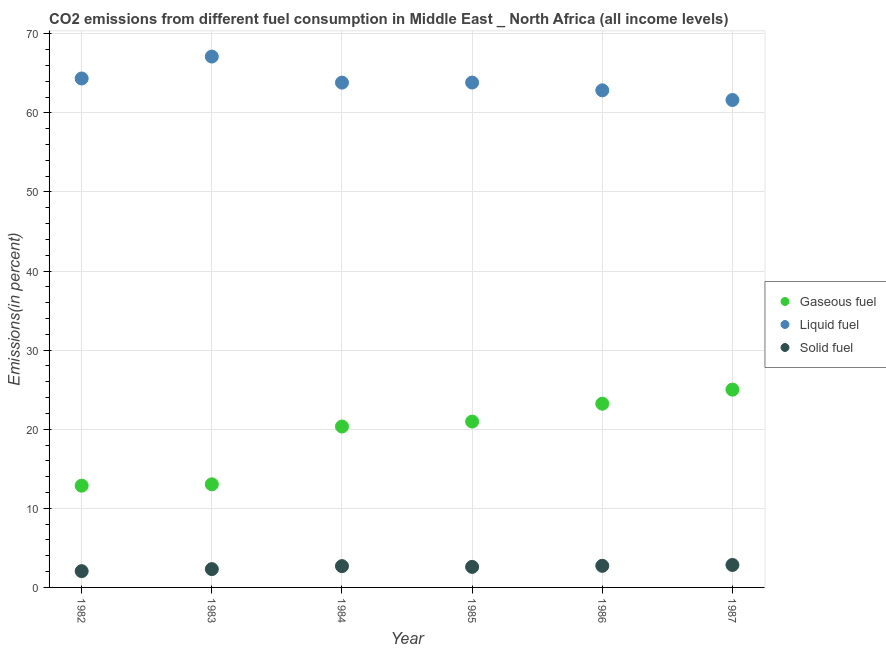How many different coloured dotlines are there?
Make the answer very short. 3. Is the number of dotlines equal to the number of legend labels?
Ensure brevity in your answer.  Yes. What is the percentage of liquid fuel emission in 1982?
Give a very brief answer. 64.35. Across all years, what is the maximum percentage of solid fuel emission?
Your answer should be very brief. 2.84. Across all years, what is the minimum percentage of gaseous fuel emission?
Offer a terse response. 12.86. In which year was the percentage of gaseous fuel emission maximum?
Your response must be concise. 1987. What is the total percentage of gaseous fuel emission in the graph?
Give a very brief answer. 115.45. What is the difference between the percentage of solid fuel emission in 1984 and that in 1986?
Make the answer very short. -0.04. What is the difference between the percentage of gaseous fuel emission in 1985 and the percentage of liquid fuel emission in 1984?
Keep it short and to the point. -42.86. What is the average percentage of liquid fuel emission per year?
Your answer should be very brief. 63.93. In the year 1983, what is the difference between the percentage of gaseous fuel emission and percentage of solid fuel emission?
Provide a succinct answer. 10.72. In how many years, is the percentage of solid fuel emission greater than 48 %?
Your answer should be very brief. 0. What is the ratio of the percentage of solid fuel emission in 1986 to that in 1987?
Give a very brief answer. 0.96. Is the percentage of solid fuel emission in 1984 less than that in 1985?
Provide a short and direct response. No. What is the difference between the highest and the second highest percentage of solid fuel emission?
Make the answer very short. 0.11. What is the difference between the highest and the lowest percentage of liquid fuel emission?
Give a very brief answer. 5.49. Is it the case that in every year, the sum of the percentage of gaseous fuel emission and percentage of liquid fuel emission is greater than the percentage of solid fuel emission?
Keep it short and to the point. Yes. Does the percentage of gaseous fuel emission monotonically increase over the years?
Your answer should be compact. Yes. Is the percentage of liquid fuel emission strictly less than the percentage of solid fuel emission over the years?
Keep it short and to the point. No. What is the difference between two consecutive major ticks on the Y-axis?
Make the answer very short. 10. Does the graph contain grids?
Provide a succinct answer. Yes. Where does the legend appear in the graph?
Keep it short and to the point. Center right. What is the title of the graph?
Offer a very short reply. CO2 emissions from different fuel consumption in Middle East _ North Africa (all income levels). What is the label or title of the Y-axis?
Your answer should be very brief. Emissions(in percent). What is the Emissions(in percent) in Gaseous fuel in 1982?
Ensure brevity in your answer.  12.86. What is the Emissions(in percent) of Liquid fuel in 1982?
Your answer should be very brief. 64.35. What is the Emissions(in percent) in Solid fuel in 1982?
Offer a terse response. 2.06. What is the Emissions(in percent) in Gaseous fuel in 1983?
Your answer should be compact. 13.04. What is the Emissions(in percent) of Liquid fuel in 1983?
Make the answer very short. 67.12. What is the Emissions(in percent) of Solid fuel in 1983?
Provide a short and direct response. 2.32. What is the Emissions(in percent) in Gaseous fuel in 1984?
Provide a succinct answer. 20.35. What is the Emissions(in percent) in Liquid fuel in 1984?
Provide a succinct answer. 63.83. What is the Emissions(in percent) in Solid fuel in 1984?
Provide a succinct answer. 2.69. What is the Emissions(in percent) of Gaseous fuel in 1985?
Your response must be concise. 20.97. What is the Emissions(in percent) in Liquid fuel in 1985?
Your answer should be compact. 63.83. What is the Emissions(in percent) of Solid fuel in 1985?
Give a very brief answer. 2.6. What is the Emissions(in percent) in Gaseous fuel in 1986?
Your answer should be compact. 23.23. What is the Emissions(in percent) of Liquid fuel in 1986?
Offer a very short reply. 62.85. What is the Emissions(in percent) in Solid fuel in 1986?
Ensure brevity in your answer.  2.73. What is the Emissions(in percent) in Gaseous fuel in 1987?
Offer a terse response. 25.01. What is the Emissions(in percent) of Liquid fuel in 1987?
Offer a very short reply. 61.63. What is the Emissions(in percent) in Solid fuel in 1987?
Your answer should be compact. 2.84. Across all years, what is the maximum Emissions(in percent) of Gaseous fuel?
Give a very brief answer. 25.01. Across all years, what is the maximum Emissions(in percent) of Liquid fuel?
Give a very brief answer. 67.12. Across all years, what is the maximum Emissions(in percent) in Solid fuel?
Your answer should be compact. 2.84. Across all years, what is the minimum Emissions(in percent) in Gaseous fuel?
Your answer should be compact. 12.86. Across all years, what is the minimum Emissions(in percent) in Liquid fuel?
Provide a short and direct response. 61.63. Across all years, what is the minimum Emissions(in percent) in Solid fuel?
Your answer should be compact. 2.06. What is the total Emissions(in percent) in Gaseous fuel in the graph?
Ensure brevity in your answer.  115.45. What is the total Emissions(in percent) in Liquid fuel in the graph?
Give a very brief answer. 383.61. What is the total Emissions(in percent) of Solid fuel in the graph?
Keep it short and to the point. 15.24. What is the difference between the Emissions(in percent) of Gaseous fuel in 1982 and that in 1983?
Make the answer very short. -0.17. What is the difference between the Emissions(in percent) of Liquid fuel in 1982 and that in 1983?
Keep it short and to the point. -2.77. What is the difference between the Emissions(in percent) in Solid fuel in 1982 and that in 1983?
Make the answer very short. -0.26. What is the difference between the Emissions(in percent) of Gaseous fuel in 1982 and that in 1984?
Ensure brevity in your answer.  -7.48. What is the difference between the Emissions(in percent) of Liquid fuel in 1982 and that in 1984?
Give a very brief answer. 0.52. What is the difference between the Emissions(in percent) of Solid fuel in 1982 and that in 1984?
Your answer should be compact. -0.63. What is the difference between the Emissions(in percent) in Gaseous fuel in 1982 and that in 1985?
Provide a succinct answer. -8.11. What is the difference between the Emissions(in percent) in Liquid fuel in 1982 and that in 1985?
Offer a very short reply. 0.52. What is the difference between the Emissions(in percent) of Solid fuel in 1982 and that in 1985?
Give a very brief answer. -0.54. What is the difference between the Emissions(in percent) of Gaseous fuel in 1982 and that in 1986?
Provide a succinct answer. -10.37. What is the difference between the Emissions(in percent) in Liquid fuel in 1982 and that in 1986?
Your answer should be very brief. 1.5. What is the difference between the Emissions(in percent) of Solid fuel in 1982 and that in 1986?
Provide a succinct answer. -0.67. What is the difference between the Emissions(in percent) of Gaseous fuel in 1982 and that in 1987?
Give a very brief answer. -12.14. What is the difference between the Emissions(in percent) in Liquid fuel in 1982 and that in 1987?
Offer a terse response. 2.72. What is the difference between the Emissions(in percent) of Solid fuel in 1982 and that in 1987?
Make the answer very short. -0.78. What is the difference between the Emissions(in percent) of Gaseous fuel in 1983 and that in 1984?
Your answer should be very brief. -7.31. What is the difference between the Emissions(in percent) in Liquid fuel in 1983 and that in 1984?
Ensure brevity in your answer.  3.3. What is the difference between the Emissions(in percent) in Solid fuel in 1983 and that in 1984?
Make the answer very short. -0.38. What is the difference between the Emissions(in percent) in Gaseous fuel in 1983 and that in 1985?
Your answer should be compact. -7.93. What is the difference between the Emissions(in percent) of Liquid fuel in 1983 and that in 1985?
Keep it short and to the point. 3.29. What is the difference between the Emissions(in percent) in Solid fuel in 1983 and that in 1985?
Offer a terse response. -0.28. What is the difference between the Emissions(in percent) in Gaseous fuel in 1983 and that in 1986?
Ensure brevity in your answer.  -10.19. What is the difference between the Emissions(in percent) in Liquid fuel in 1983 and that in 1986?
Offer a very short reply. 4.27. What is the difference between the Emissions(in percent) in Solid fuel in 1983 and that in 1986?
Your answer should be very brief. -0.42. What is the difference between the Emissions(in percent) of Gaseous fuel in 1983 and that in 1987?
Provide a succinct answer. -11.97. What is the difference between the Emissions(in percent) of Liquid fuel in 1983 and that in 1987?
Offer a very short reply. 5.49. What is the difference between the Emissions(in percent) of Solid fuel in 1983 and that in 1987?
Provide a short and direct response. -0.53. What is the difference between the Emissions(in percent) of Gaseous fuel in 1984 and that in 1985?
Make the answer very short. -0.62. What is the difference between the Emissions(in percent) of Liquid fuel in 1984 and that in 1985?
Provide a succinct answer. -0.01. What is the difference between the Emissions(in percent) in Solid fuel in 1984 and that in 1985?
Offer a terse response. 0.09. What is the difference between the Emissions(in percent) in Gaseous fuel in 1984 and that in 1986?
Your answer should be very brief. -2.88. What is the difference between the Emissions(in percent) in Liquid fuel in 1984 and that in 1986?
Your answer should be very brief. 0.98. What is the difference between the Emissions(in percent) of Solid fuel in 1984 and that in 1986?
Keep it short and to the point. -0.04. What is the difference between the Emissions(in percent) in Gaseous fuel in 1984 and that in 1987?
Provide a short and direct response. -4.66. What is the difference between the Emissions(in percent) of Liquid fuel in 1984 and that in 1987?
Your answer should be very brief. 2.2. What is the difference between the Emissions(in percent) in Solid fuel in 1984 and that in 1987?
Provide a short and direct response. -0.15. What is the difference between the Emissions(in percent) of Gaseous fuel in 1985 and that in 1986?
Offer a terse response. -2.26. What is the difference between the Emissions(in percent) in Liquid fuel in 1985 and that in 1986?
Offer a terse response. 0.98. What is the difference between the Emissions(in percent) in Solid fuel in 1985 and that in 1986?
Give a very brief answer. -0.13. What is the difference between the Emissions(in percent) in Gaseous fuel in 1985 and that in 1987?
Ensure brevity in your answer.  -4.04. What is the difference between the Emissions(in percent) in Liquid fuel in 1985 and that in 1987?
Give a very brief answer. 2.21. What is the difference between the Emissions(in percent) in Solid fuel in 1985 and that in 1987?
Your answer should be compact. -0.24. What is the difference between the Emissions(in percent) in Gaseous fuel in 1986 and that in 1987?
Ensure brevity in your answer.  -1.78. What is the difference between the Emissions(in percent) in Liquid fuel in 1986 and that in 1987?
Your response must be concise. 1.22. What is the difference between the Emissions(in percent) of Solid fuel in 1986 and that in 1987?
Ensure brevity in your answer.  -0.11. What is the difference between the Emissions(in percent) in Gaseous fuel in 1982 and the Emissions(in percent) in Liquid fuel in 1983?
Keep it short and to the point. -54.26. What is the difference between the Emissions(in percent) of Gaseous fuel in 1982 and the Emissions(in percent) of Solid fuel in 1983?
Offer a very short reply. 10.55. What is the difference between the Emissions(in percent) of Liquid fuel in 1982 and the Emissions(in percent) of Solid fuel in 1983?
Ensure brevity in your answer.  62.03. What is the difference between the Emissions(in percent) of Gaseous fuel in 1982 and the Emissions(in percent) of Liquid fuel in 1984?
Your answer should be very brief. -50.96. What is the difference between the Emissions(in percent) of Gaseous fuel in 1982 and the Emissions(in percent) of Solid fuel in 1984?
Keep it short and to the point. 10.17. What is the difference between the Emissions(in percent) in Liquid fuel in 1982 and the Emissions(in percent) in Solid fuel in 1984?
Ensure brevity in your answer.  61.66. What is the difference between the Emissions(in percent) of Gaseous fuel in 1982 and the Emissions(in percent) of Liquid fuel in 1985?
Provide a short and direct response. -50.97. What is the difference between the Emissions(in percent) of Gaseous fuel in 1982 and the Emissions(in percent) of Solid fuel in 1985?
Keep it short and to the point. 10.27. What is the difference between the Emissions(in percent) in Liquid fuel in 1982 and the Emissions(in percent) in Solid fuel in 1985?
Your answer should be very brief. 61.75. What is the difference between the Emissions(in percent) in Gaseous fuel in 1982 and the Emissions(in percent) in Liquid fuel in 1986?
Provide a short and direct response. -49.99. What is the difference between the Emissions(in percent) in Gaseous fuel in 1982 and the Emissions(in percent) in Solid fuel in 1986?
Offer a terse response. 10.13. What is the difference between the Emissions(in percent) in Liquid fuel in 1982 and the Emissions(in percent) in Solid fuel in 1986?
Your answer should be compact. 61.62. What is the difference between the Emissions(in percent) in Gaseous fuel in 1982 and the Emissions(in percent) in Liquid fuel in 1987?
Offer a very short reply. -48.76. What is the difference between the Emissions(in percent) in Gaseous fuel in 1982 and the Emissions(in percent) in Solid fuel in 1987?
Your answer should be very brief. 10.02. What is the difference between the Emissions(in percent) of Liquid fuel in 1982 and the Emissions(in percent) of Solid fuel in 1987?
Keep it short and to the point. 61.51. What is the difference between the Emissions(in percent) in Gaseous fuel in 1983 and the Emissions(in percent) in Liquid fuel in 1984?
Your answer should be very brief. -50.79. What is the difference between the Emissions(in percent) of Gaseous fuel in 1983 and the Emissions(in percent) of Solid fuel in 1984?
Provide a succinct answer. 10.34. What is the difference between the Emissions(in percent) of Liquid fuel in 1983 and the Emissions(in percent) of Solid fuel in 1984?
Provide a short and direct response. 64.43. What is the difference between the Emissions(in percent) of Gaseous fuel in 1983 and the Emissions(in percent) of Liquid fuel in 1985?
Your response must be concise. -50.8. What is the difference between the Emissions(in percent) of Gaseous fuel in 1983 and the Emissions(in percent) of Solid fuel in 1985?
Your answer should be compact. 10.44. What is the difference between the Emissions(in percent) of Liquid fuel in 1983 and the Emissions(in percent) of Solid fuel in 1985?
Your answer should be very brief. 64.52. What is the difference between the Emissions(in percent) of Gaseous fuel in 1983 and the Emissions(in percent) of Liquid fuel in 1986?
Make the answer very short. -49.81. What is the difference between the Emissions(in percent) of Gaseous fuel in 1983 and the Emissions(in percent) of Solid fuel in 1986?
Give a very brief answer. 10.3. What is the difference between the Emissions(in percent) in Liquid fuel in 1983 and the Emissions(in percent) in Solid fuel in 1986?
Provide a succinct answer. 64.39. What is the difference between the Emissions(in percent) of Gaseous fuel in 1983 and the Emissions(in percent) of Liquid fuel in 1987?
Your response must be concise. -48.59. What is the difference between the Emissions(in percent) of Gaseous fuel in 1983 and the Emissions(in percent) of Solid fuel in 1987?
Keep it short and to the point. 10.2. What is the difference between the Emissions(in percent) in Liquid fuel in 1983 and the Emissions(in percent) in Solid fuel in 1987?
Your response must be concise. 64.28. What is the difference between the Emissions(in percent) in Gaseous fuel in 1984 and the Emissions(in percent) in Liquid fuel in 1985?
Ensure brevity in your answer.  -43.49. What is the difference between the Emissions(in percent) in Gaseous fuel in 1984 and the Emissions(in percent) in Solid fuel in 1985?
Your response must be concise. 17.75. What is the difference between the Emissions(in percent) of Liquid fuel in 1984 and the Emissions(in percent) of Solid fuel in 1985?
Your response must be concise. 61.23. What is the difference between the Emissions(in percent) of Gaseous fuel in 1984 and the Emissions(in percent) of Liquid fuel in 1986?
Your response must be concise. -42.5. What is the difference between the Emissions(in percent) in Gaseous fuel in 1984 and the Emissions(in percent) in Solid fuel in 1986?
Make the answer very short. 17.61. What is the difference between the Emissions(in percent) in Liquid fuel in 1984 and the Emissions(in percent) in Solid fuel in 1986?
Your answer should be compact. 61.09. What is the difference between the Emissions(in percent) in Gaseous fuel in 1984 and the Emissions(in percent) in Liquid fuel in 1987?
Your answer should be very brief. -41.28. What is the difference between the Emissions(in percent) in Gaseous fuel in 1984 and the Emissions(in percent) in Solid fuel in 1987?
Make the answer very short. 17.51. What is the difference between the Emissions(in percent) of Liquid fuel in 1984 and the Emissions(in percent) of Solid fuel in 1987?
Your answer should be compact. 60.98. What is the difference between the Emissions(in percent) in Gaseous fuel in 1985 and the Emissions(in percent) in Liquid fuel in 1986?
Provide a succinct answer. -41.88. What is the difference between the Emissions(in percent) in Gaseous fuel in 1985 and the Emissions(in percent) in Solid fuel in 1986?
Your response must be concise. 18.24. What is the difference between the Emissions(in percent) of Liquid fuel in 1985 and the Emissions(in percent) of Solid fuel in 1986?
Your response must be concise. 61.1. What is the difference between the Emissions(in percent) in Gaseous fuel in 1985 and the Emissions(in percent) in Liquid fuel in 1987?
Offer a terse response. -40.66. What is the difference between the Emissions(in percent) in Gaseous fuel in 1985 and the Emissions(in percent) in Solid fuel in 1987?
Your response must be concise. 18.13. What is the difference between the Emissions(in percent) in Liquid fuel in 1985 and the Emissions(in percent) in Solid fuel in 1987?
Your answer should be compact. 60.99. What is the difference between the Emissions(in percent) of Gaseous fuel in 1986 and the Emissions(in percent) of Liquid fuel in 1987?
Provide a succinct answer. -38.4. What is the difference between the Emissions(in percent) of Gaseous fuel in 1986 and the Emissions(in percent) of Solid fuel in 1987?
Give a very brief answer. 20.39. What is the difference between the Emissions(in percent) in Liquid fuel in 1986 and the Emissions(in percent) in Solid fuel in 1987?
Your answer should be very brief. 60.01. What is the average Emissions(in percent) of Gaseous fuel per year?
Your answer should be very brief. 19.24. What is the average Emissions(in percent) of Liquid fuel per year?
Give a very brief answer. 63.93. What is the average Emissions(in percent) of Solid fuel per year?
Ensure brevity in your answer.  2.54. In the year 1982, what is the difference between the Emissions(in percent) in Gaseous fuel and Emissions(in percent) in Liquid fuel?
Your answer should be very brief. -51.49. In the year 1982, what is the difference between the Emissions(in percent) of Gaseous fuel and Emissions(in percent) of Solid fuel?
Keep it short and to the point. 10.81. In the year 1982, what is the difference between the Emissions(in percent) in Liquid fuel and Emissions(in percent) in Solid fuel?
Your answer should be very brief. 62.29. In the year 1983, what is the difference between the Emissions(in percent) in Gaseous fuel and Emissions(in percent) in Liquid fuel?
Offer a terse response. -54.09. In the year 1983, what is the difference between the Emissions(in percent) of Gaseous fuel and Emissions(in percent) of Solid fuel?
Make the answer very short. 10.72. In the year 1983, what is the difference between the Emissions(in percent) of Liquid fuel and Emissions(in percent) of Solid fuel?
Offer a very short reply. 64.81. In the year 1984, what is the difference between the Emissions(in percent) in Gaseous fuel and Emissions(in percent) in Liquid fuel?
Keep it short and to the point. -43.48. In the year 1984, what is the difference between the Emissions(in percent) in Gaseous fuel and Emissions(in percent) in Solid fuel?
Your answer should be very brief. 17.65. In the year 1984, what is the difference between the Emissions(in percent) in Liquid fuel and Emissions(in percent) in Solid fuel?
Keep it short and to the point. 61.13. In the year 1985, what is the difference between the Emissions(in percent) in Gaseous fuel and Emissions(in percent) in Liquid fuel?
Offer a very short reply. -42.86. In the year 1985, what is the difference between the Emissions(in percent) in Gaseous fuel and Emissions(in percent) in Solid fuel?
Give a very brief answer. 18.37. In the year 1985, what is the difference between the Emissions(in percent) in Liquid fuel and Emissions(in percent) in Solid fuel?
Provide a succinct answer. 61.23. In the year 1986, what is the difference between the Emissions(in percent) of Gaseous fuel and Emissions(in percent) of Liquid fuel?
Offer a very short reply. -39.62. In the year 1986, what is the difference between the Emissions(in percent) of Gaseous fuel and Emissions(in percent) of Solid fuel?
Your response must be concise. 20.5. In the year 1986, what is the difference between the Emissions(in percent) in Liquid fuel and Emissions(in percent) in Solid fuel?
Ensure brevity in your answer.  60.12. In the year 1987, what is the difference between the Emissions(in percent) in Gaseous fuel and Emissions(in percent) in Liquid fuel?
Make the answer very short. -36.62. In the year 1987, what is the difference between the Emissions(in percent) of Gaseous fuel and Emissions(in percent) of Solid fuel?
Your response must be concise. 22.17. In the year 1987, what is the difference between the Emissions(in percent) of Liquid fuel and Emissions(in percent) of Solid fuel?
Offer a very short reply. 58.79. What is the ratio of the Emissions(in percent) of Gaseous fuel in 1982 to that in 1983?
Keep it short and to the point. 0.99. What is the ratio of the Emissions(in percent) in Liquid fuel in 1982 to that in 1983?
Offer a terse response. 0.96. What is the ratio of the Emissions(in percent) in Solid fuel in 1982 to that in 1983?
Your response must be concise. 0.89. What is the ratio of the Emissions(in percent) of Gaseous fuel in 1982 to that in 1984?
Provide a short and direct response. 0.63. What is the ratio of the Emissions(in percent) in Liquid fuel in 1982 to that in 1984?
Give a very brief answer. 1.01. What is the ratio of the Emissions(in percent) of Solid fuel in 1982 to that in 1984?
Offer a very short reply. 0.76. What is the ratio of the Emissions(in percent) in Gaseous fuel in 1982 to that in 1985?
Your response must be concise. 0.61. What is the ratio of the Emissions(in percent) of Liquid fuel in 1982 to that in 1985?
Offer a terse response. 1.01. What is the ratio of the Emissions(in percent) in Solid fuel in 1982 to that in 1985?
Ensure brevity in your answer.  0.79. What is the ratio of the Emissions(in percent) in Gaseous fuel in 1982 to that in 1986?
Provide a short and direct response. 0.55. What is the ratio of the Emissions(in percent) in Liquid fuel in 1982 to that in 1986?
Ensure brevity in your answer.  1.02. What is the ratio of the Emissions(in percent) of Solid fuel in 1982 to that in 1986?
Your answer should be compact. 0.75. What is the ratio of the Emissions(in percent) of Gaseous fuel in 1982 to that in 1987?
Your answer should be very brief. 0.51. What is the ratio of the Emissions(in percent) in Liquid fuel in 1982 to that in 1987?
Make the answer very short. 1.04. What is the ratio of the Emissions(in percent) of Solid fuel in 1982 to that in 1987?
Offer a terse response. 0.72. What is the ratio of the Emissions(in percent) in Gaseous fuel in 1983 to that in 1984?
Provide a succinct answer. 0.64. What is the ratio of the Emissions(in percent) of Liquid fuel in 1983 to that in 1984?
Your answer should be very brief. 1.05. What is the ratio of the Emissions(in percent) of Solid fuel in 1983 to that in 1984?
Ensure brevity in your answer.  0.86. What is the ratio of the Emissions(in percent) of Gaseous fuel in 1983 to that in 1985?
Your answer should be very brief. 0.62. What is the ratio of the Emissions(in percent) in Liquid fuel in 1983 to that in 1985?
Your response must be concise. 1.05. What is the ratio of the Emissions(in percent) in Solid fuel in 1983 to that in 1985?
Ensure brevity in your answer.  0.89. What is the ratio of the Emissions(in percent) in Gaseous fuel in 1983 to that in 1986?
Give a very brief answer. 0.56. What is the ratio of the Emissions(in percent) in Liquid fuel in 1983 to that in 1986?
Provide a short and direct response. 1.07. What is the ratio of the Emissions(in percent) in Solid fuel in 1983 to that in 1986?
Keep it short and to the point. 0.85. What is the ratio of the Emissions(in percent) of Gaseous fuel in 1983 to that in 1987?
Provide a short and direct response. 0.52. What is the ratio of the Emissions(in percent) of Liquid fuel in 1983 to that in 1987?
Provide a short and direct response. 1.09. What is the ratio of the Emissions(in percent) of Solid fuel in 1983 to that in 1987?
Your answer should be compact. 0.82. What is the ratio of the Emissions(in percent) in Gaseous fuel in 1984 to that in 1985?
Your answer should be very brief. 0.97. What is the ratio of the Emissions(in percent) of Liquid fuel in 1984 to that in 1985?
Your response must be concise. 1. What is the ratio of the Emissions(in percent) of Solid fuel in 1984 to that in 1985?
Your answer should be very brief. 1.04. What is the ratio of the Emissions(in percent) of Gaseous fuel in 1984 to that in 1986?
Keep it short and to the point. 0.88. What is the ratio of the Emissions(in percent) of Liquid fuel in 1984 to that in 1986?
Your answer should be compact. 1.02. What is the ratio of the Emissions(in percent) of Solid fuel in 1984 to that in 1986?
Your answer should be very brief. 0.99. What is the ratio of the Emissions(in percent) in Gaseous fuel in 1984 to that in 1987?
Your answer should be very brief. 0.81. What is the ratio of the Emissions(in percent) in Liquid fuel in 1984 to that in 1987?
Keep it short and to the point. 1.04. What is the ratio of the Emissions(in percent) of Solid fuel in 1984 to that in 1987?
Your answer should be very brief. 0.95. What is the ratio of the Emissions(in percent) in Gaseous fuel in 1985 to that in 1986?
Offer a terse response. 0.9. What is the ratio of the Emissions(in percent) in Liquid fuel in 1985 to that in 1986?
Provide a short and direct response. 1.02. What is the ratio of the Emissions(in percent) in Solid fuel in 1985 to that in 1986?
Provide a succinct answer. 0.95. What is the ratio of the Emissions(in percent) of Gaseous fuel in 1985 to that in 1987?
Your answer should be compact. 0.84. What is the ratio of the Emissions(in percent) in Liquid fuel in 1985 to that in 1987?
Give a very brief answer. 1.04. What is the ratio of the Emissions(in percent) of Solid fuel in 1985 to that in 1987?
Your answer should be compact. 0.91. What is the ratio of the Emissions(in percent) in Gaseous fuel in 1986 to that in 1987?
Make the answer very short. 0.93. What is the ratio of the Emissions(in percent) in Liquid fuel in 1986 to that in 1987?
Your answer should be compact. 1.02. What is the ratio of the Emissions(in percent) of Solid fuel in 1986 to that in 1987?
Your response must be concise. 0.96. What is the difference between the highest and the second highest Emissions(in percent) of Gaseous fuel?
Your answer should be very brief. 1.78. What is the difference between the highest and the second highest Emissions(in percent) of Liquid fuel?
Provide a succinct answer. 2.77. What is the difference between the highest and the second highest Emissions(in percent) of Solid fuel?
Give a very brief answer. 0.11. What is the difference between the highest and the lowest Emissions(in percent) in Gaseous fuel?
Offer a very short reply. 12.14. What is the difference between the highest and the lowest Emissions(in percent) in Liquid fuel?
Ensure brevity in your answer.  5.49. What is the difference between the highest and the lowest Emissions(in percent) of Solid fuel?
Offer a terse response. 0.78. 